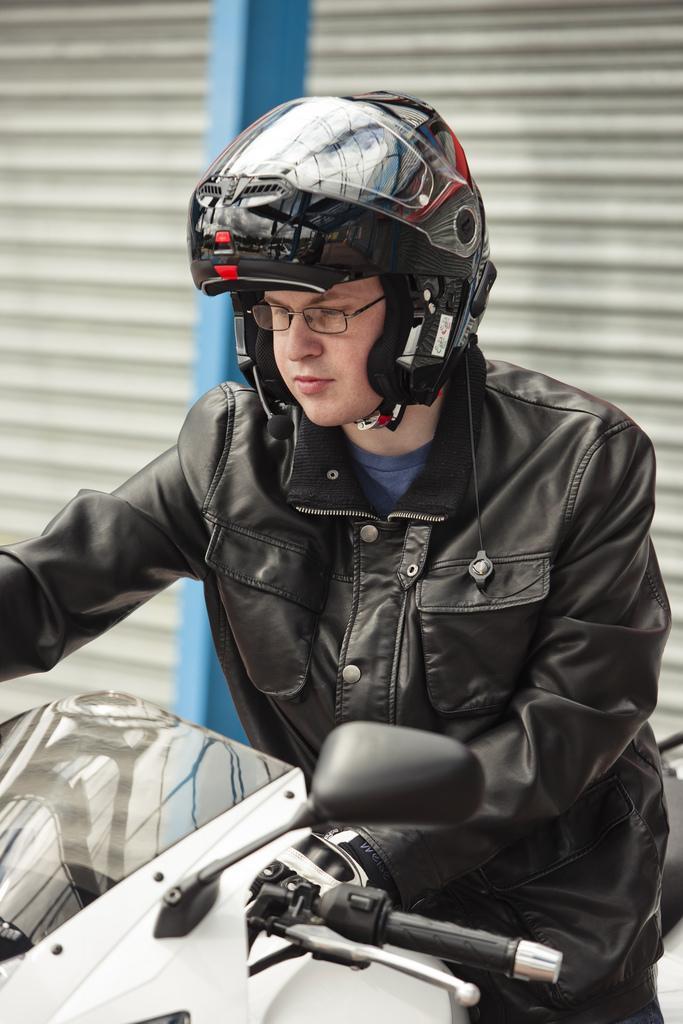Describe this image in one or two sentences. In this picture there is a man who is wearing helmet, spectacle, jacket and trouser. He is standing near to the bike. Behind him I can see the shelter and blue color pole. 